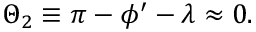Convert formula to latex. <formula><loc_0><loc_0><loc_500><loc_500>\Theta _ { 2 } \equiv \pi - \phi ^ { \prime } - \lambda \approx 0 .</formula> 